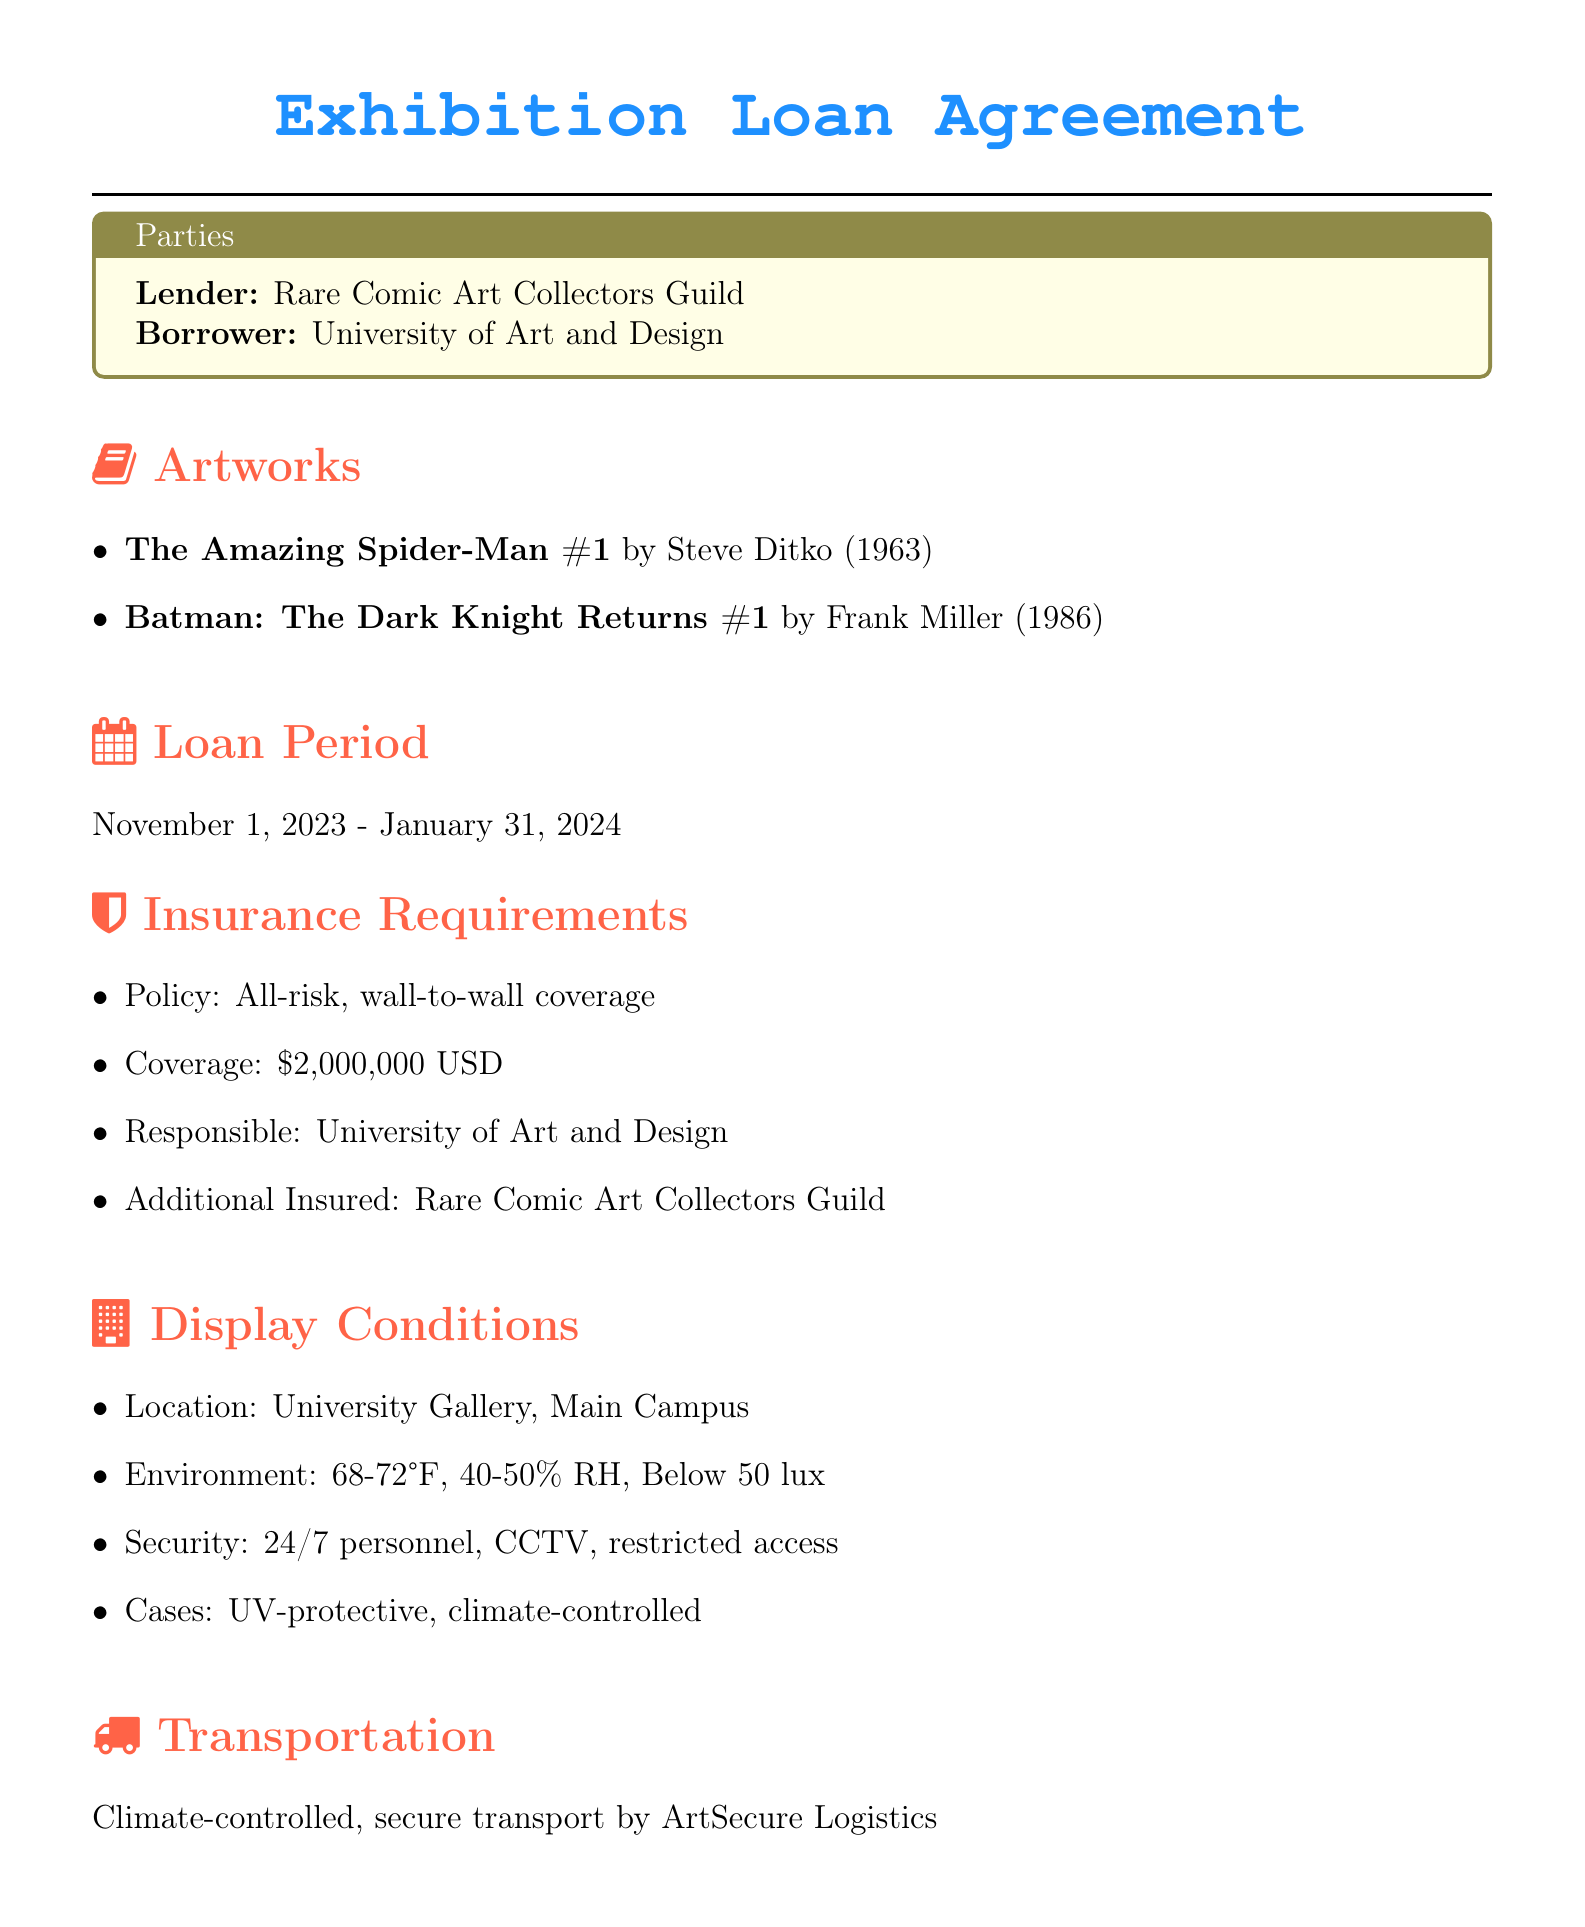What is the name of the lender? The name of the lender is specified in the document's Parties section, which states that it is the Rare Comic Art Collectors Guild.
Answer: Rare Comic Art Collectors Guild What is the display location for the artworks? The display location is mentioned under the Display Conditions section, indicating it will be in the University Gallery, Main Campus.
Answer: University Gallery, Main Campus What is the total insurance coverage amount? The insurance coverage amount can be found in the Insurance Requirements section, which states it is $2,000,000 USD.
Answer: $2,000,000 USD What is the loan period duration? The loan period is specified in the Loan Period section, detailing the timeframe from November 1, 2023, to January 31, 2024.
Answer: November 1, 2023 - January 31, 2024 How many artworks are being loaned? The number of artworks is indicated in the Artworks section, where two specific comic book titles are listed.
Answer: 2 What temperature range is required for the display environment? The required temperature range is found in the Display Conditions section, detailing that it should be between 68-72°F.
Answer: 68-72°F Who is responsible for the insurance policy? The responsible party for the insurance policy is identified in the Insurance Requirements section, which notes it is the University of Art and Design.
Answer: University of Art and Design What is required when handling the artworks? This is stated in the Conservation & Return section, which indicates that gloves are required for handling.
Answer: Gloves required What type of transport is specified for the artworks? The type of transport used is outlined in the Transportation section, which states that it is climate-controlled and secure transport.
Answer: Climate-controlled, secure transport 